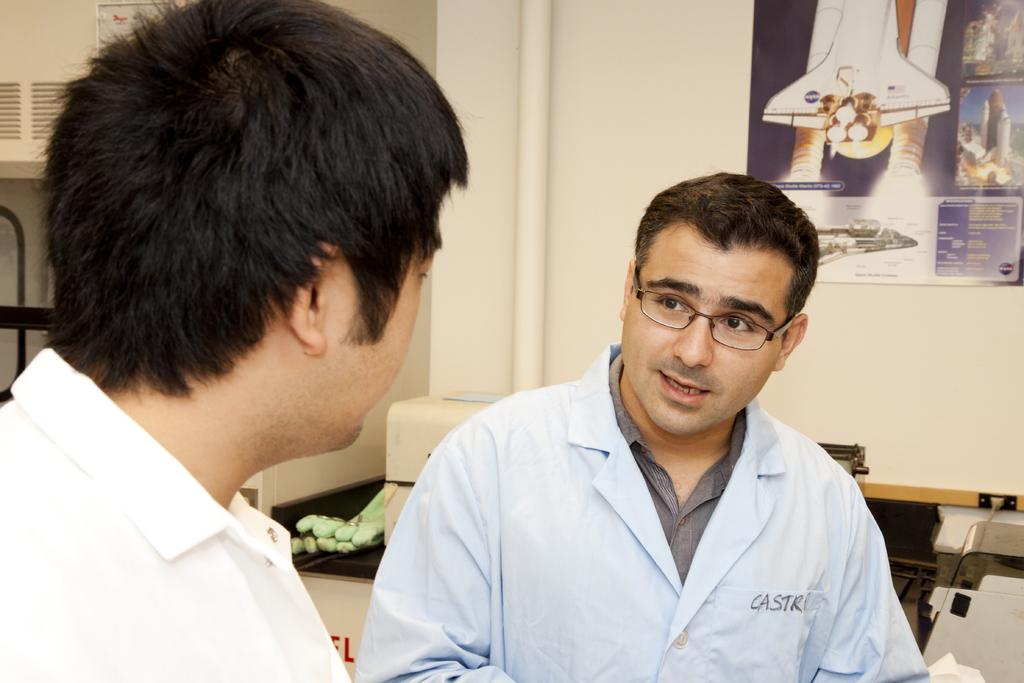What can be seen in the image? There are persons standing in the image. What is visible in the background of the image? There are objects in the background of the image, including gloves and a stand. What is the wall in the image like? There is a wall in the image, and it has a poster with images on it. What type of record can be seen on the wall in the image? There is no record present on the wall in the image; it has a poster with images on it. What is the aftermath of the button in the image? There is no button present in the image, so there is no aftermath to discuss. 